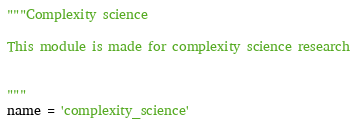Convert code to text. <code><loc_0><loc_0><loc_500><loc_500><_Python_>"""Complexity science 

This module is made for complexity science research


"""
name = 'complexity_science'
</code> 